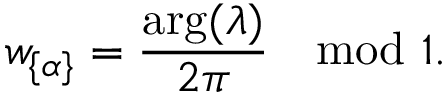Convert formula to latex. <formula><loc_0><loc_0><loc_500><loc_500>w _ { \{ \alpha \} } = \frac { \arg ( \lambda ) } { 2 \pi } \mod 1 .</formula> 